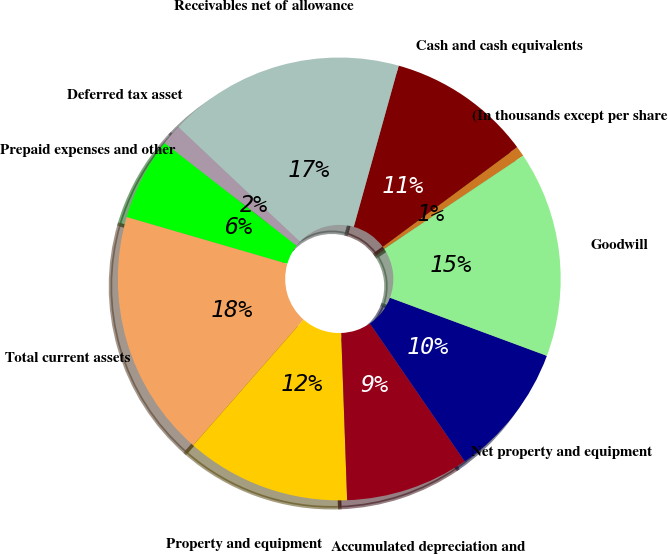Convert chart. <chart><loc_0><loc_0><loc_500><loc_500><pie_chart><fcel>(In thousands except per share<fcel>Cash and cash equivalents<fcel>Receivables net of allowance<fcel>Deferred tax asset<fcel>Prepaid expenses and other<fcel>Total current assets<fcel>Property and equipment<fcel>Accumulated depreciation and<fcel>Net property and equipment<fcel>Goodwill<nl><fcel>0.75%<fcel>10.53%<fcel>17.29%<fcel>1.51%<fcel>6.02%<fcel>18.04%<fcel>12.03%<fcel>9.02%<fcel>9.77%<fcel>15.04%<nl></chart> 